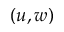Convert formula to latex. <formula><loc_0><loc_0><loc_500><loc_500>( u , w )</formula> 